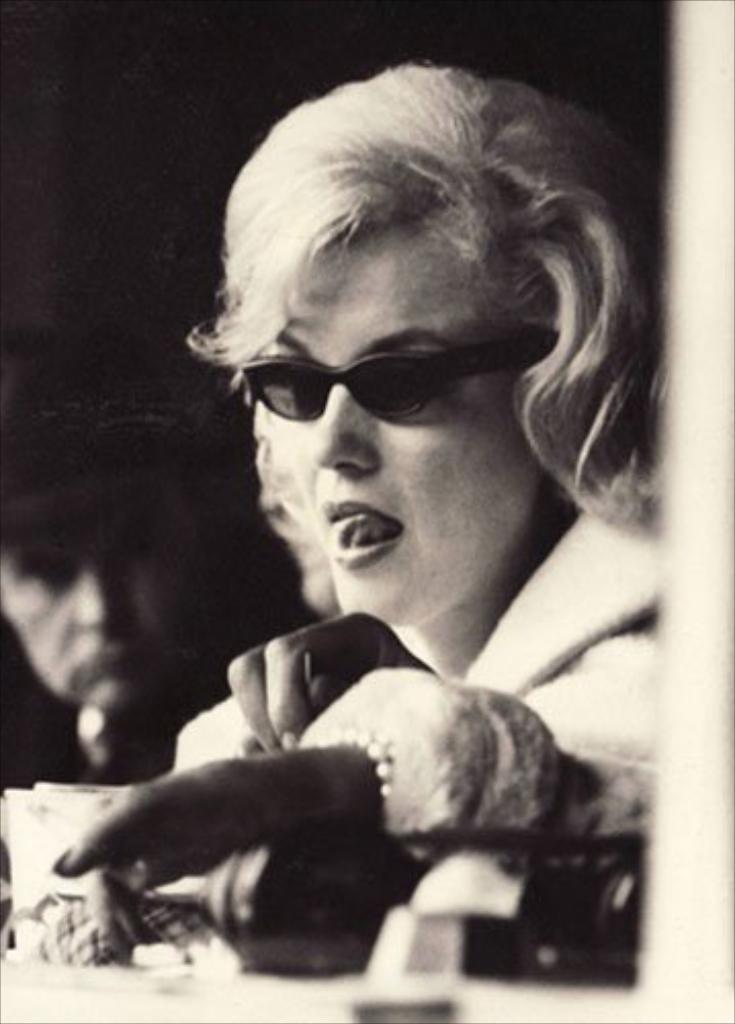Can you describe this image briefly? In the picture we can see a black and white photograph of a woman sitting near the desk and she is with black color goggles and beside her we can see another person face. 